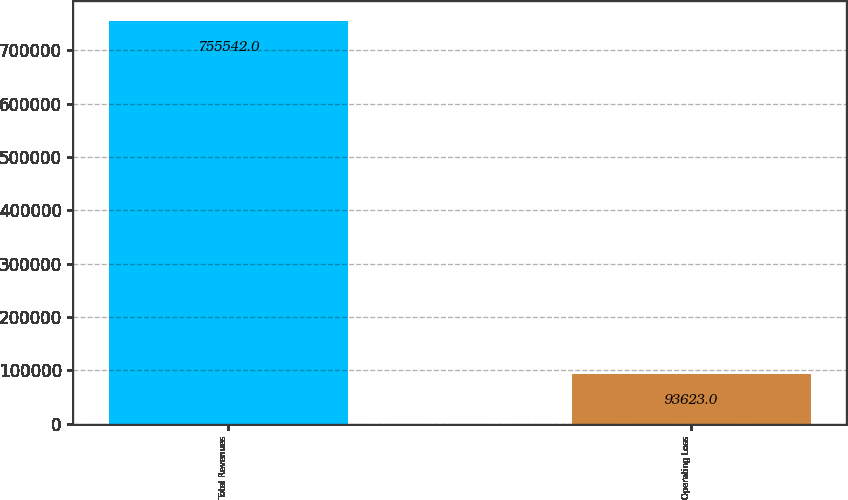Convert chart to OTSL. <chart><loc_0><loc_0><loc_500><loc_500><bar_chart><fcel>Total Revenues<fcel>Operating Loss<nl><fcel>755542<fcel>93623<nl></chart> 